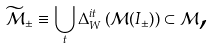Convert formula to latex. <formula><loc_0><loc_0><loc_500><loc_500>\widetilde { \mathcal { M } } _ { \pm } \equiv \bigcup _ { t } \Delta _ { W } ^ { i t } \left ( \mathcal { M } ( I _ { \pm } ) \right ) \subset \mathcal { M } \text {,}</formula> 